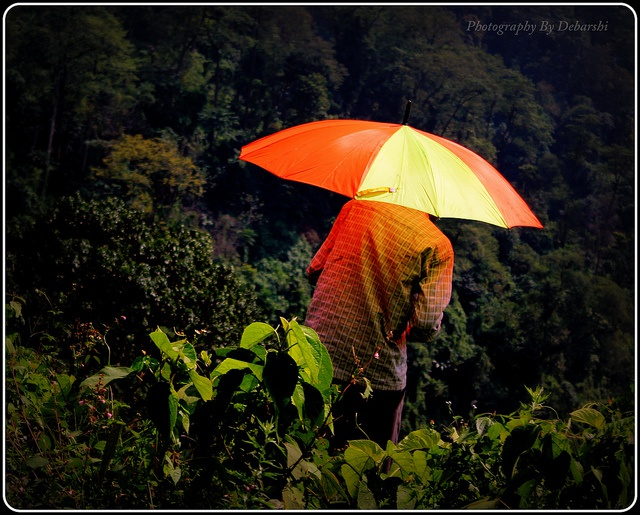Describe the objects in this image and their specific colors. I can see people in black, maroon, brown, and red tones and umbrella in black, khaki, red, and salmon tones in this image. 